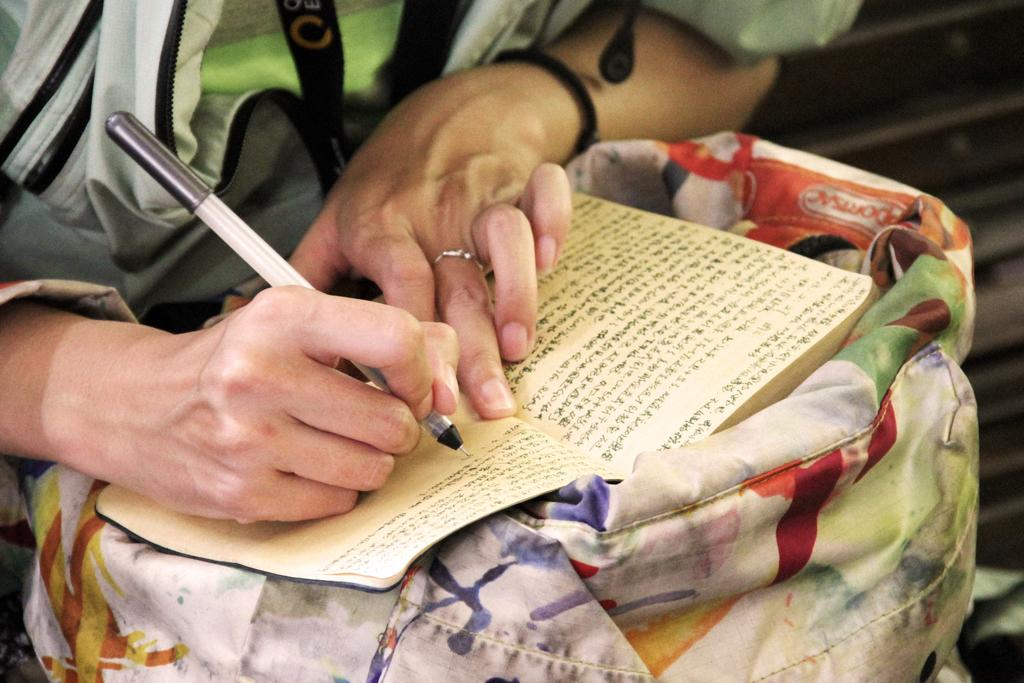What is the main subject of the image? There is a person in the image. What is the person wearing? The person is wearing a dress. What objects is the person holding? The person is holding a book and a pen. Can you describe the background of the image? The background of the image is blurred. What type of fan is visible in the image? There is no fan present in the image. What discovery was made by the person in the image? The image does not depict any discovery being made. 